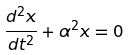Convert formula to latex. <formula><loc_0><loc_0><loc_500><loc_500>\frac { d ^ { 2 } x } { d t ^ { 2 } } + \alpha ^ { 2 } x = 0</formula> 